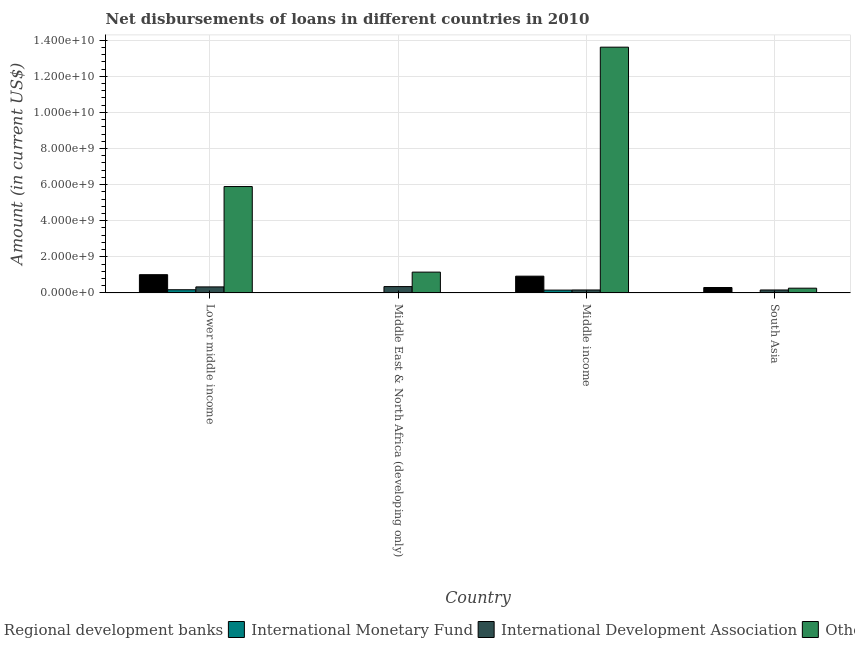How many different coloured bars are there?
Your answer should be very brief. 4. How many groups of bars are there?
Provide a short and direct response. 4. Are the number of bars per tick equal to the number of legend labels?
Make the answer very short. No. Are the number of bars on each tick of the X-axis equal?
Ensure brevity in your answer.  No. How many bars are there on the 3rd tick from the left?
Provide a succinct answer. 4. How many bars are there on the 1st tick from the right?
Make the answer very short. 3. What is the label of the 2nd group of bars from the left?
Ensure brevity in your answer.  Middle East & North Africa (developing only). What is the amount of loan disimbursed by international development association in Middle income?
Offer a terse response. 1.64e+08. Across all countries, what is the maximum amount of loan disimbursed by international monetary fund?
Offer a terse response. 1.77e+08. Across all countries, what is the minimum amount of loan disimbursed by international development association?
Provide a short and direct response. 1.64e+08. In which country was the amount of loan disimbursed by international monetary fund maximum?
Keep it short and to the point. Lower middle income. What is the total amount of loan disimbursed by international development association in the graph?
Provide a succinct answer. 1.01e+09. What is the difference between the amount of loan disimbursed by regional development banks in Middle income and that in South Asia?
Ensure brevity in your answer.  6.28e+08. What is the difference between the amount of loan disimbursed by international monetary fund in Middle income and the amount of loan disimbursed by international development association in South Asia?
Give a very brief answer. -7.22e+06. What is the average amount of loan disimbursed by international development association per country?
Provide a succinct answer. 2.54e+08. What is the difference between the amount of loan disimbursed by other organisations and amount of loan disimbursed by international development association in Middle income?
Offer a very short reply. 1.34e+1. What is the ratio of the amount of loan disimbursed by other organisations in Middle income to that in South Asia?
Your response must be concise. 51.66. What is the difference between the highest and the second highest amount of loan disimbursed by regional development banks?
Your answer should be compact. 8.16e+07. What is the difference between the highest and the lowest amount of loan disimbursed by other organisations?
Make the answer very short. 1.34e+1. In how many countries, is the amount of loan disimbursed by regional development banks greater than the average amount of loan disimbursed by regional development banks taken over all countries?
Make the answer very short. 2. Is the sum of the amount of loan disimbursed by international monetary fund in Lower middle income and Middle income greater than the maximum amount of loan disimbursed by international development association across all countries?
Provide a short and direct response. No. Is it the case that in every country, the sum of the amount of loan disimbursed by regional development banks and amount of loan disimbursed by international monetary fund is greater than the amount of loan disimbursed by international development association?
Offer a terse response. No. How many bars are there?
Keep it short and to the point. 14. Are all the bars in the graph horizontal?
Provide a succinct answer. No. What is the difference between two consecutive major ticks on the Y-axis?
Your answer should be very brief. 2.00e+09. Does the graph contain grids?
Offer a terse response. Yes. How many legend labels are there?
Make the answer very short. 4. What is the title of the graph?
Ensure brevity in your answer.  Net disbursements of loans in different countries in 2010. What is the label or title of the X-axis?
Make the answer very short. Country. What is the label or title of the Y-axis?
Make the answer very short. Amount (in current US$). What is the Amount (in current US$) of Regional development banks in Lower middle income?
Give a very brief answer. 1.01e+09. What is the Amount (in current US$) in International Monetary Fund in Lower middle income?
Keep it short and to the point. 1.77e+08. What is the Amount (in current US$) of International Development Association in Lower middle income?
Provide a short and direct response. 3.34e+08. What is the Amount (in current US$) in Others in Lower middle income?
Ensure brevity in your answer.  5.89e+09. What is the Amount (in current US$) in Regional development banks in Middle East & North Africa (developing only)?
Offer a terse response. 0. What is the Amount (in current US$) in International Monetary Fund in Middle East & North Africa (developing only)?
Your answer should be compact. 2.27e+07. What is the Amount (in current US$) in International Development Association in Middle East & North Africa (developing only)?
Your answer should be compact. 3.52e+08. What is the Amount (in current US$) of Others in Middle East & North Africa (developing only)?
Provide a succinct answer. 1.15e+09. What is the Amount (in current US$) in Regional development banks in Middle income?
Give a very brief answer. 9.30e+08. What is the Amount (in current US$) of International Monetary Fund in Middle income?
Your answer should be compact. 1.57e+08. What is the Amount (in current US$) in International Development Association in Middle income?
Your response must be concise. 1.64e+08. What is the Amount (in current US$) of Others in Middle income?
Your response must be concise. 1.36e+1. What is the Amount (in current US$) of Regional development banks in South Asia?
Keep it short and to the point. 3.01e+08. What is the Amount (in current US$) of International Monetary Fund in South Asia?
Your answer should be compact. 0. What is the Amount (in current US$) of International Development Association in South Asia?
Provide a succinct answer. 1.64e+08. What is the Amount (in current US$) of Others in South Asia?
Your response must be concise. 2.64e+08. Across all countries, what is the maximum Amount (in current US$) in Regional development banks?
Your answer should be compact. 1.01e+09. Across all countries, what is the maximum Amount (in current US$) in International Monetary Fund?
Offer a terse response. 1.77e+08. Across all countries, what is the maximum Amount (in current US$) of International Development Association?
Offer a very short reply. 3.52e+08. Across all countries, what is the maximum Amount (in current US$) of Others?
Provide a short and direct response. 1.36e+1. Across all countries, what is the minimum Amount (in current US$) in Regional development banks?
Make the answer very short. 0. Across all countries, what is the minimum Amount (in current US$) of International Monetary Fund?
Your answer should be very brief. 0. Across all countries, what is the minimum Amount (in current US$) in International Development Association?
Make the answer very short. 1.64e+08. Across all countries, what is the minimum Amount (in current US$) of Others?
Offer a very short reply. 2.64e+08. What is the total Amount (in current US$) in Regional development banks in the graph?
Provide a short and direct response. 2.24e+09. What is the total Amount (in current US$) of International Monetary Fund in the graph?
Give a very brief answer. 3.57e+08. What is the total Amount (in current US$) of International Development Association in the graph?
Provide a succinct answer. 1.01e+09. What is the total Amount (in current US$) in Others in the graph?
Make the answer very short. 2.09e+1. What is the difference between the Amount (in current US$) of International Monetary Fund in Lower middle income and that in Middle East & North Africa (developing only)?
Your answer should be compact. 1.55e+08. What is the difference between the Amount (in current US$) in International Development Association in Lower middle income and that in Middle East & North Africa (developing only)?
Offer a terse response. -1.73e+07. What is the difference between the Amount (in current US$) in Others in Lower middle income and that in Middle East & North Africa (developing only)?
Offer a terse response. 4.74e+09. What is the difference between the Amount (in current US$) in Regional development banks in Lower middle income and that in Middle income?
Offer a terse response. 8.16e+07. What is the difference between the Amount (in current US$) in International Monetary Fund in Lower middle income and that in Middle income?
Your answer should be compact. 2.00e+07. What is the difference between the Amount (in current US$) of International Development Association in Lower middle income and that in Middle income?
Provide a succinct answer. 1.70e+08. What is the difference between the Amount (in current US$) in Others in Lower middle income and that in Middle income?
Offer a very short reply. -7.72e+09. What is the difference between the Amount (in current US$) in Regional development banks in Lower middle income and that in South Asia?
Provide a short and direct response. 7.10e+08. What is the difference between the Amount (in current US$) of International Development Association in Lower middle income and that in South Asia?
Keep it short and to the point. 1.70e+08. What is the difference between the Amount (in current US$) of Others in Lower middle income and that in South Asia?
Offer a very short reply. 5.63e+09. What is the difference between the Amount (in current US$) of International Monetary Fund in Middle East & North Africa (developing only) and that in Middle income?
Give a very brief answer. -1.35e+08. What is the difference between the Amount (in current US$) in International Development Association in Middle East & North Africa (developing only) and that in Middle income?
Offer a terse response. 1.87e+08. What is the difference between the Amount (in current US$) in Others in Middle East & North Africa (developing only) and that in Middle income?
Ensure brevity in your answer.  -1.25e+1. What is the difference between the Amount (in current US$) of International Development Association in Middle East & North Africa (developing only) and that in South Asia?
Provide a succinct answer. 1.87e+08. What is the difference between the Amount (in current US$) in Others in Middle East & North Africa (developing only) and that in South Asia?
Your response must be concise. 8.90e+08. What is the difference between the Amount (in current US$) in Regional development banks in Middle income and that in South Asia?
Provide a succinct answer. 6.28e+08. What is the difference between the Amount (in current US$) of International Development Association in Middle income and that in South Asia?
Give a very brief answer. -4.20e+04. What is the difference between the Amount (in current US$) in Others in Middle income and that in South Asia?
Provide a succinct answer. 1.34e+1. What is the difference between the Amount (in current US$) in Regional development banks in Lower middle income and the Amount (in current US$) in International Monetary Fund in Middle East & North Africa (developing only)?
Your answer should be compact. 9.88e+08. What is the difference between the Amount (in current US$) in Regional development banks in Lower middle income and the Amount (in current US$) in International Development Association in Middle East & North Africa (developing only)?
Provide a short and direct response. 6.60e+08. What is the difference between the Amount (in current US$) of Regional development banks in Lower middle income and the Amount (in current US$) of Others in Middle East & North Africa (developing only)?
Keep it short and to the point. -1.42e+08. What is the difference between the Amount (in current US$) in International Monetary Fund in Lower middle income and the Amount (in current US$) in International Development Association in Middle East & North Africa (developing only)?
Ensure brevity in your answer.  -1.74e+08. What is the difference between the Amount (in current US$) of International Monetary Fund in Lower middle income and the Amount (in current US$) of Others in Middle East & North Africa (developing only)?
Provide a short and direct response. -9.76e+08. What is the difference between the Amount (in current US$) in International Development Association in Lower middle income and the Amount (in current US$) in Others in Middle East & North Africa (developing only)?
Give a very brief answer. -8.19e+08. What is the difference between the Amount (in current US$) of Regional development banks in Lower middle income and the Amount (in current US$) of International Monetary Fund in Middle income?
Your response must be concise. 8.54e+08. What is the difference between the Amount (in current US$) of Regional development banks in Lower middle income and the Amount (in current US$) of International Development Association in Middle income?
Offer a terse response. 8.47e+08. What is the difference between the Amount (in current US$) of Regional development banks in Lower middle income and the Amount (in current US$) of Others in Middle income?
Offer a very short reply. -1.26e+1. What is the difference between the Amount (in current US$) in International Monetary Fund in Lower middle income and the Amount (in current US$) in International Development Association in Middle income?
Provide a succinct answer. 1.28e+07. What is the difference between the Amount (in current US$) in International Monetary Fund in Lower middle income and the Amount (in current US$) in Others in Middle income?
Give a very brief answer. -1.34e+1. What is the difference between the Amount (in current US$) in International Development Association in Lower middle income and the Amount (in current US$) in Others in Middle income?
Give a very brief answer. -1.33e+1. What is the difference between the Amount (in current US$) of Regional development banks in Lower middle income and the Amount (in current US$) of International Development Association in South Asia?
Keep it short and to the point. 8.47e+08. What is the difference between the Amount (in current US$) of Regional development banks in Lower middle income and the Amount (in current US$) of Others in South Asia?
Ensure brevity in your answer.  7.48e+08. What is the difference between the Amount (in current US$) in International Monetary Fund in Lower middle income and the Amount (in current US$) in International Development Association in South Asia?
Your response must be concise. 1.27e+07. What is the difference between the Amount (in current US$) in International Monetary Fund in Lower middle income and the Amount (in current US$) in Others in South Asia?
Your answer should be very brief. -8.63e+07. What is the difference between the Amount (in current US$) in International Development Association in Lower middle income and the Amount (in current US$) in Others in South Asia?
Provide a short and direct response. 7.07e+07. What is the difference between the Amount (in current US$) in International Monetary Fund in Middle East & North Africa (developing only) and the Amount (in current US$) in International Development Association in Middle income?
Ensure brevity in your answer.  -1.42e+08. What is the difference between the Amount (in current US$) of International Monetary Fund in Middle East & North Africa (developing only) and the Amount (in current US$) of Others in Middle income?
Your answer should be very brief. -1.36e+1. What is the difference between the Amount (in current US$) in International Development Association in Middle East & North Africa (developing only) and the Amount (in current US$) in Others in Middle income?
Offer a very short reply. -1.33e+1. What is the difference between the Amount (in current US$) of International Monetary Fund in Middle East & North Africa (developing only) and the Amount (in current US$) of International Development Association in South Asia?
Provide a succinct answer. -1.42e+08. What is the difference between the Amount (in current US$) in International Monetary Fund in Middle East & North Africa (developing only) and the Amount (in current US$) in Others in South Asia?
Your answer should be very brief. -2.41e+08. What is the difference between the Amount (in current US$) in International Development Association in Middle East & North Africa (developing only) and the Amount (in current US$) in Others in South Asia?
Keep it short and to the point. 8.80e+07. What is the difference between the Amount (in current US$) in Regional development banks in Middle income and the Amount (in current US$) in International Development Association in South Asia?
Your answer should be very brief. 7.65e+08. What is the difference between the Amount (in current US$) of Regional development banks in Middle income and the Amount (in current US$) of Others in South Asia?
Your answer should be very brief. 6.66e+08. What is the difference between the Amount (in current US$) of International Monetary Fund in Middle income and the Amount (in current US$) of International Development Association in South Asia?
Offer a very short reply. -7.22e+06. What is the difference between the Amount (in current US$) in International Monetary Fund in Middle income and the Amount (in current US$) in Others in South Asia?
Your answer should be very brief. -1.06e+08. What is the difference between the Amount (in current US$) in International Development Association in Middle income and the Amount (in current US$) in Others in South Asia?
Give a very brief answer. -9.91e+07. What is the average Amount (in current US$) in Regional development banks per country?
Give a very brief answer. 5.60e+08. What is the average Amount (in current US$) in International Monetary Fund per country?
Make the answer very short. 8.93e+07. What is the average Amount (in current US$) in International Development Association per country?
Provide a succinct answer. 2.54e+08. What is the average Amount (in current US$) in Others per country?
Your answer should be very brief. 5.23e+09. What is the difference between the Amount (in current US$) in Regional development banks and Amount (in current US$) in International Monetary Fund in Lower middle income?
Ensure brevity in your answer.  8.34e+08. What is the difference between the Amount (in current US$) in Regional development banks and Amount (in current US$) in International Development Association in Lower middle income?
Your answer should be compact. 6.77e+08. What is the difference between the Amount (in current US$) in Regional development banks and Amount (in current US$) in Others in Lower middle income?
Give a very brief answer. -4.88e+09. What is the difference between the Amount (in current US$) in International Monetary Fund and Amount (in current US$) in International Development Association in Lower middle income?
Make the answer very short. -1.57e+08. What is the difference between the Amount (in current US$) in International Monetary Fund and Amount (in current US$) in Others in Lower middle income?
Your answer should be very brief. -5.72e+09. What is the difference between the Amount (in current US$) of International Development Association and Amount (in current US$) of Others in Lower middle income?
Make the answer very short. -5.56e+09. What is the difference between the Amount (in current US$) of International Monetary Fund and Amount (in current US$) of International Development Association in Middle East & North Africa (developing only)?
Provide a short and direct response. -3.29e+08. What is the difference between the Amount (in current US$) of International Monetary Fund and Amount (in current US$) of Others in Middle East & North Africa (developing only)?
Offer a very short reply. -1.13e+09. What is the difference between the Amount (in current US$) in International Development Association and Amount (in current US$) in Others in Middle East & North Africa (developing only)?
Your response must be concise. -8.02e+08. What is the difference between the Amount (in current US$) in Regional development banks and Amount (in current US$) in International Monetary Fund in Middle income?
Provide a short and direct response. 7.72e+08. What is the difference between the Amount (in current US$) in Regional development banks and Amount (in current US$) in International Development Association in Middle income?
Your response must be concise. 7.65e+08. What is the difference between the Amount (in current US$) in Regional development banks and Amount (in current US$) in Others in Middle income?
Your answer should be very brief. -1.27e+1. What is the difference between the Amount (in current US$) in International Monetary Fund and Amount (in current US$) in International Development Association in Middle income?
Offer a terse response. -7.18e+06. What is the difference between the Amount (in current US$) in International Monetary Fund and Amount (in current US$) in Others in Middle income?
Provide a succinct answer. -1.35e+1. What is the difference between the Amount (in current US$) in International Development Association and Amount (in current US$) in Others in Middle income?
Ensure brevity in your answer.  -1.34e+1. What is the difference between the Amount (in current US$) of Regional development banks and Amount (in current US$) of International Development Association in South Asia?
Ensure brevity in your answer.  1.37e+08. What is the difference between the Amount (in current US$) of Regional development banks and Amount (in current US$) of Others in South Asia?
Provide a succinct answer. 3.76e+07. What is the difference between the Amount (in current US$) of International Development Association and Amount (in current US$) of Others in South Asia?
Your answer should be compact. -9.91e+07. What is the ratio of the Amount (in current US$) of International Monetary Fund in Lower middle income to that in Middle East & North Africa (developing only)?
Provide a succinct answer. 7.82. What is the ratio of the Amount (in current US$) in International Development Association in Lower middle income to that in Middle East & North Africa (developing only)?
Provide a succinct answer. 0.95. What is the ratio of the Amount (in current US$) of Others in Lower middle income to that in Middle East & North Africa (developing only)?
Your answer should be very brief. 5.11. What is the ratio of the Amount (in current US$) in Regional development banks in Lower middle income to that in Middle income?
Offer a very short reply. 1.09. What is the ratio of the Amount (in current US$) in International Monetary Fund in Lower middle income to that in Middle income?
Your answer should be very brief. 1.13. What is the ratio of the Amount (in current US$) in International Development Association in Lower middle income to that in Middle income?
Make the answer very short. 2.03. What is the ratio of the Amount (in current US$) of Others in Lower middle income to that in Middle income?
Provide a short and direct response. 0.43. What is the ratio of the Amount (in current US$) of Regional development banks in Lower middle income to that in South Asia?
Ensure brevity in your answer.  3.36. What is the ratio of the Amount (in current US$) of International Development Association in Lower middle income to that in South Asia?
Provide a short and direct response. 2.03. What is the ratio of the Amount (in current US$) in Others in Lower middle income to that in South Asia?
Provide a succinct answer. 22.36. What is the ratio of the Amount (in current US$) in International Monetary Fund in Middle East & North Africa (developing only) to that in Middle income?
Offer a very short reply. 0.14. What is the ratio of the Amount (in current US$) of International Development Association in Middle East & North Africa (developing only) to that in Middle income?
Make the answer very short. 2.14. What is the ratio of the Amount (in current US$) of Others in Middle East & North Africa (developing only) to that in Middle income?
Give a very brief answer. 0.08. What is the ratio of the Amount (in current US$) of International Development Association in Middle East & North Africa (developing only) to that in South Asia?
Provide a succinct answer. 2.14. What is the ratio of the Amount (in current US$) of Others in Middle East & North Africa (developing only) to that in South Asia?
Give a very brief answer. 4.38. What is the ratio of the Amount (in current US$) in Regional development banks in Middle income to that in South Asia?
Offer a terse response. 3.09. What is the ratio of the Amount (in current US$) in International Development Association in Middle income to that in South Asia?
Keep it short and to the point. 1. What is the ratio of the Amount (in current US$) in Others in Middle income to that in South Asia?
Your response must be concise. 51.66. What is the difference between the highest and the second highest Amount (in current US$) of Regional development banks?
Provide a succinct answer. 8.16e+07. What is the difference between the highest and the second highest Amount (in current US$) in International Monetary Fund?
Give a very brief answer. 2.00e+07. What is the difference between the highest and the second highest Amount (in current US$) of International Development Association?
Make the answer very short. 1.73e+07. What is the difference between the highest and the second highest Amount (in current US$) in Others?
Your answer should be very brief. 7.72e+09. What is the difference between the highest and the lowest Amount (in current US$) of Regional development banks?
Make the answer very short. 1.01e+09. What is the difference between the highest and the lowest Amount (in current US$) in International Monetary Fund?
Make the answer very short. 1.77e+08. What is the difference between the highest and the lowest Amount (in current US$) of International Development Association?
Offer a very short reply. 1.87e+08. What is the difference between the highest and the lowest Amount (in current US$) of Others?
Offer a terse response. 1.34e+1. 